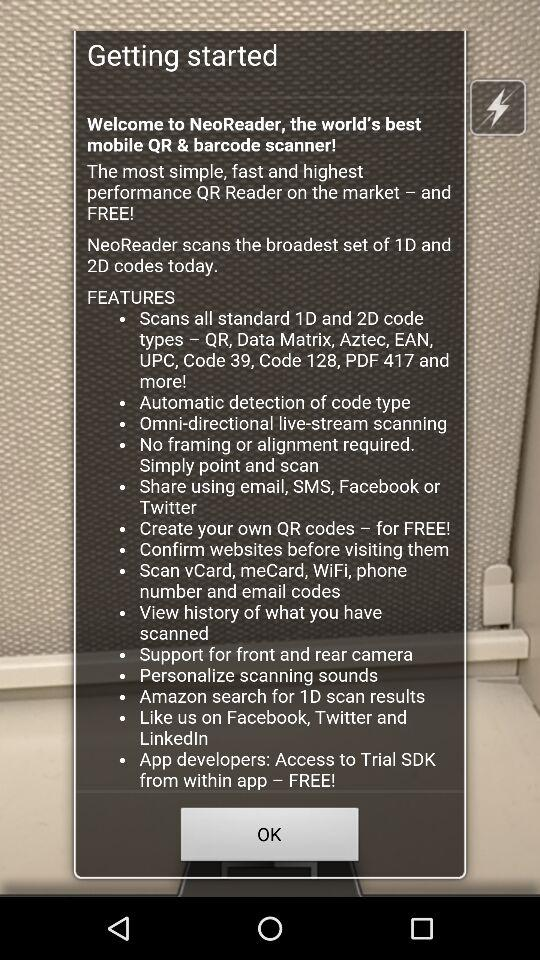What history can we view? You can view the history of what you have scanned. 